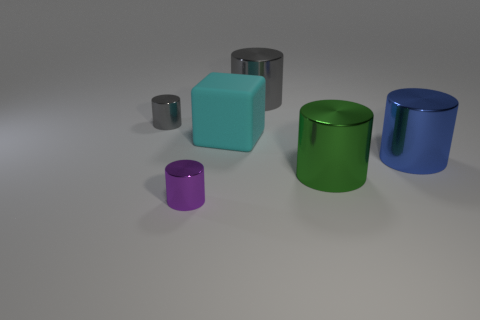Can you describe the arrangement of the objects and their sizes in relation to each other? Certainly! The image showcases a variety of objects with different sizes. Foremost, there's a small purple cylinder which appears to be the smallest followed by a tiny gray cylinder. A medium-sized teal-blue cube and a larger green cylinder reside in the middle ground, while a big blue cylinder anchors the composition to the right. The arrangement and different sizes create a sense of depth and scale in the image. 